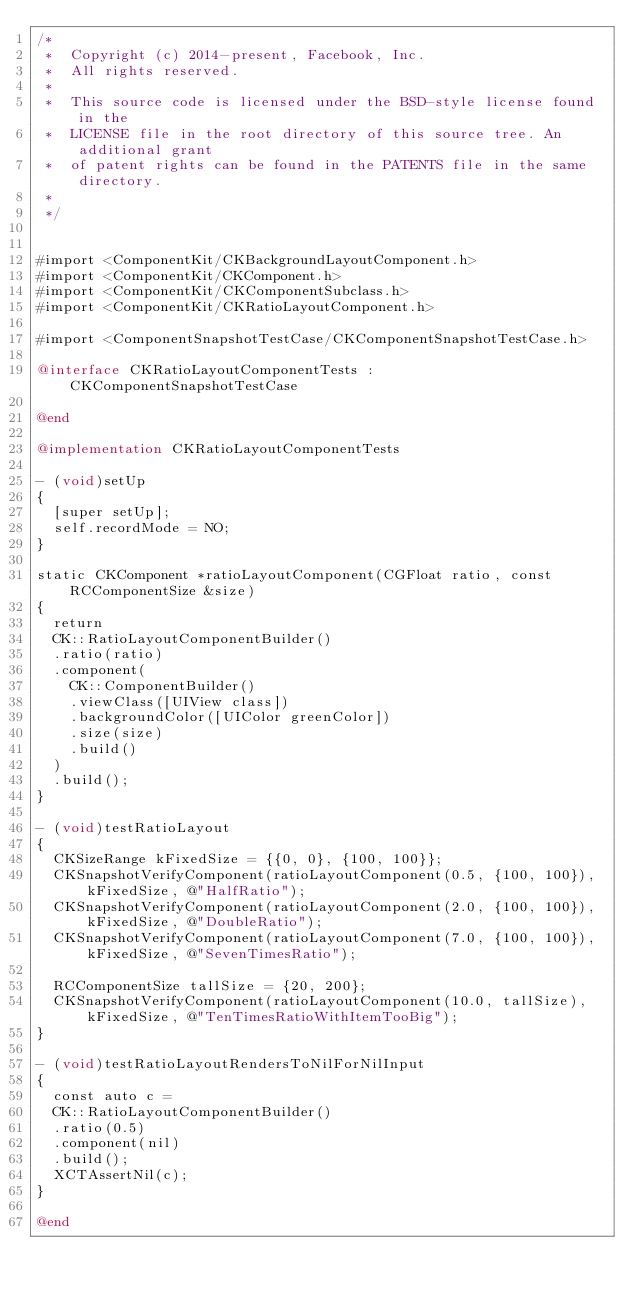Convert code to text. <code><loc_0><loc_0><loc_500><loc_500><_ObjectiveC_>/*
 *  Copyright (c) 2014-present, Facebook, Inc.
 *  All rights reserved.
 *
 *  This source code is licensed under the BSD-style license found in the
 *  LICENSE file in the root directory of this source tree. An additional grant
 *  of patent rights can be found in the PATENTS file in the same directory.
 *
 */


#import <ComponentKit/CKBackgroundLayoutComponent.h>
#import <ComponentKit/CKComponent.h>
#import <ComponentKit/CKComponentSubclass.h>
#import <ComponentKit/CKRatioLayoutComponent.h>

#import <ComponentSnapshotTestCase/CKComponentSnapshotTestCase.h>

@interface CKRatioLayoutComponentTests : CKComponentSnapshotTestCase

@end

@implementation CKRatioLayoutComponentTests

- (void)setUp
{
  [super setUp];
  self.recordMode = NO;
}

static CKComponent *ratioLayoutComponent(CGFloat ratio, const RCComponentSize &size)
{
  return
  CK::RatioLayoutComponentBuilder()
  .ratio(ratio)
  .component(
    CK::ComponentBuilder()
    .viewClass([UIView class])
    .backgroundColor([UIColor greenColor])
    .size(size)
    .build()
  )
  .build();
}

- (void)testRatioLayout
{
  CKSizeRange kFixedSize = {{0, 0}, {100, 100}};
  CKSnapshotVerifyComponent(ratioLayoutComponent(0.5, {100, 100}), kFixedSize, @"HalfRatio");
  CKSnapshotVerifyComponent(ratioLayoutComponent(2.0, {100, 100}), kFixedSize, @"DoubleRatio");
  CKSnapshotVerifyComponent(ratioLayoutComponent(7.0, {100, 100}), kFixedSize, @"SevenTimesRatio");

  RCComponentSize tallSize = {20, 200};
  CKSnapshotVerifyComponent(ratioLayoutComponent(10.0, tallSize), kFixedSize, @"TenTimesRatioWithItemTooBig");
}

- (void)testRatioLayoutRendersToNilForNilInput
{
  const auto c =
  CK::RatioLayoutComponentBuilder()
  .ratio(0.5)
  .component(nil)
  .build();
  XCTAssertNil(c);
}

@end
</code> 